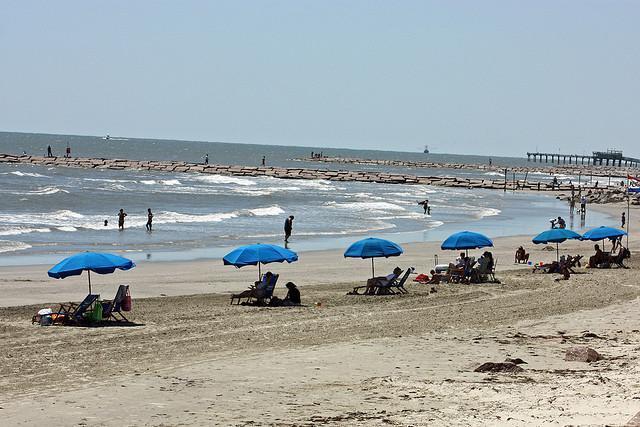How many blue umbrellas line the beach?
Give a very brief answer. 6. 